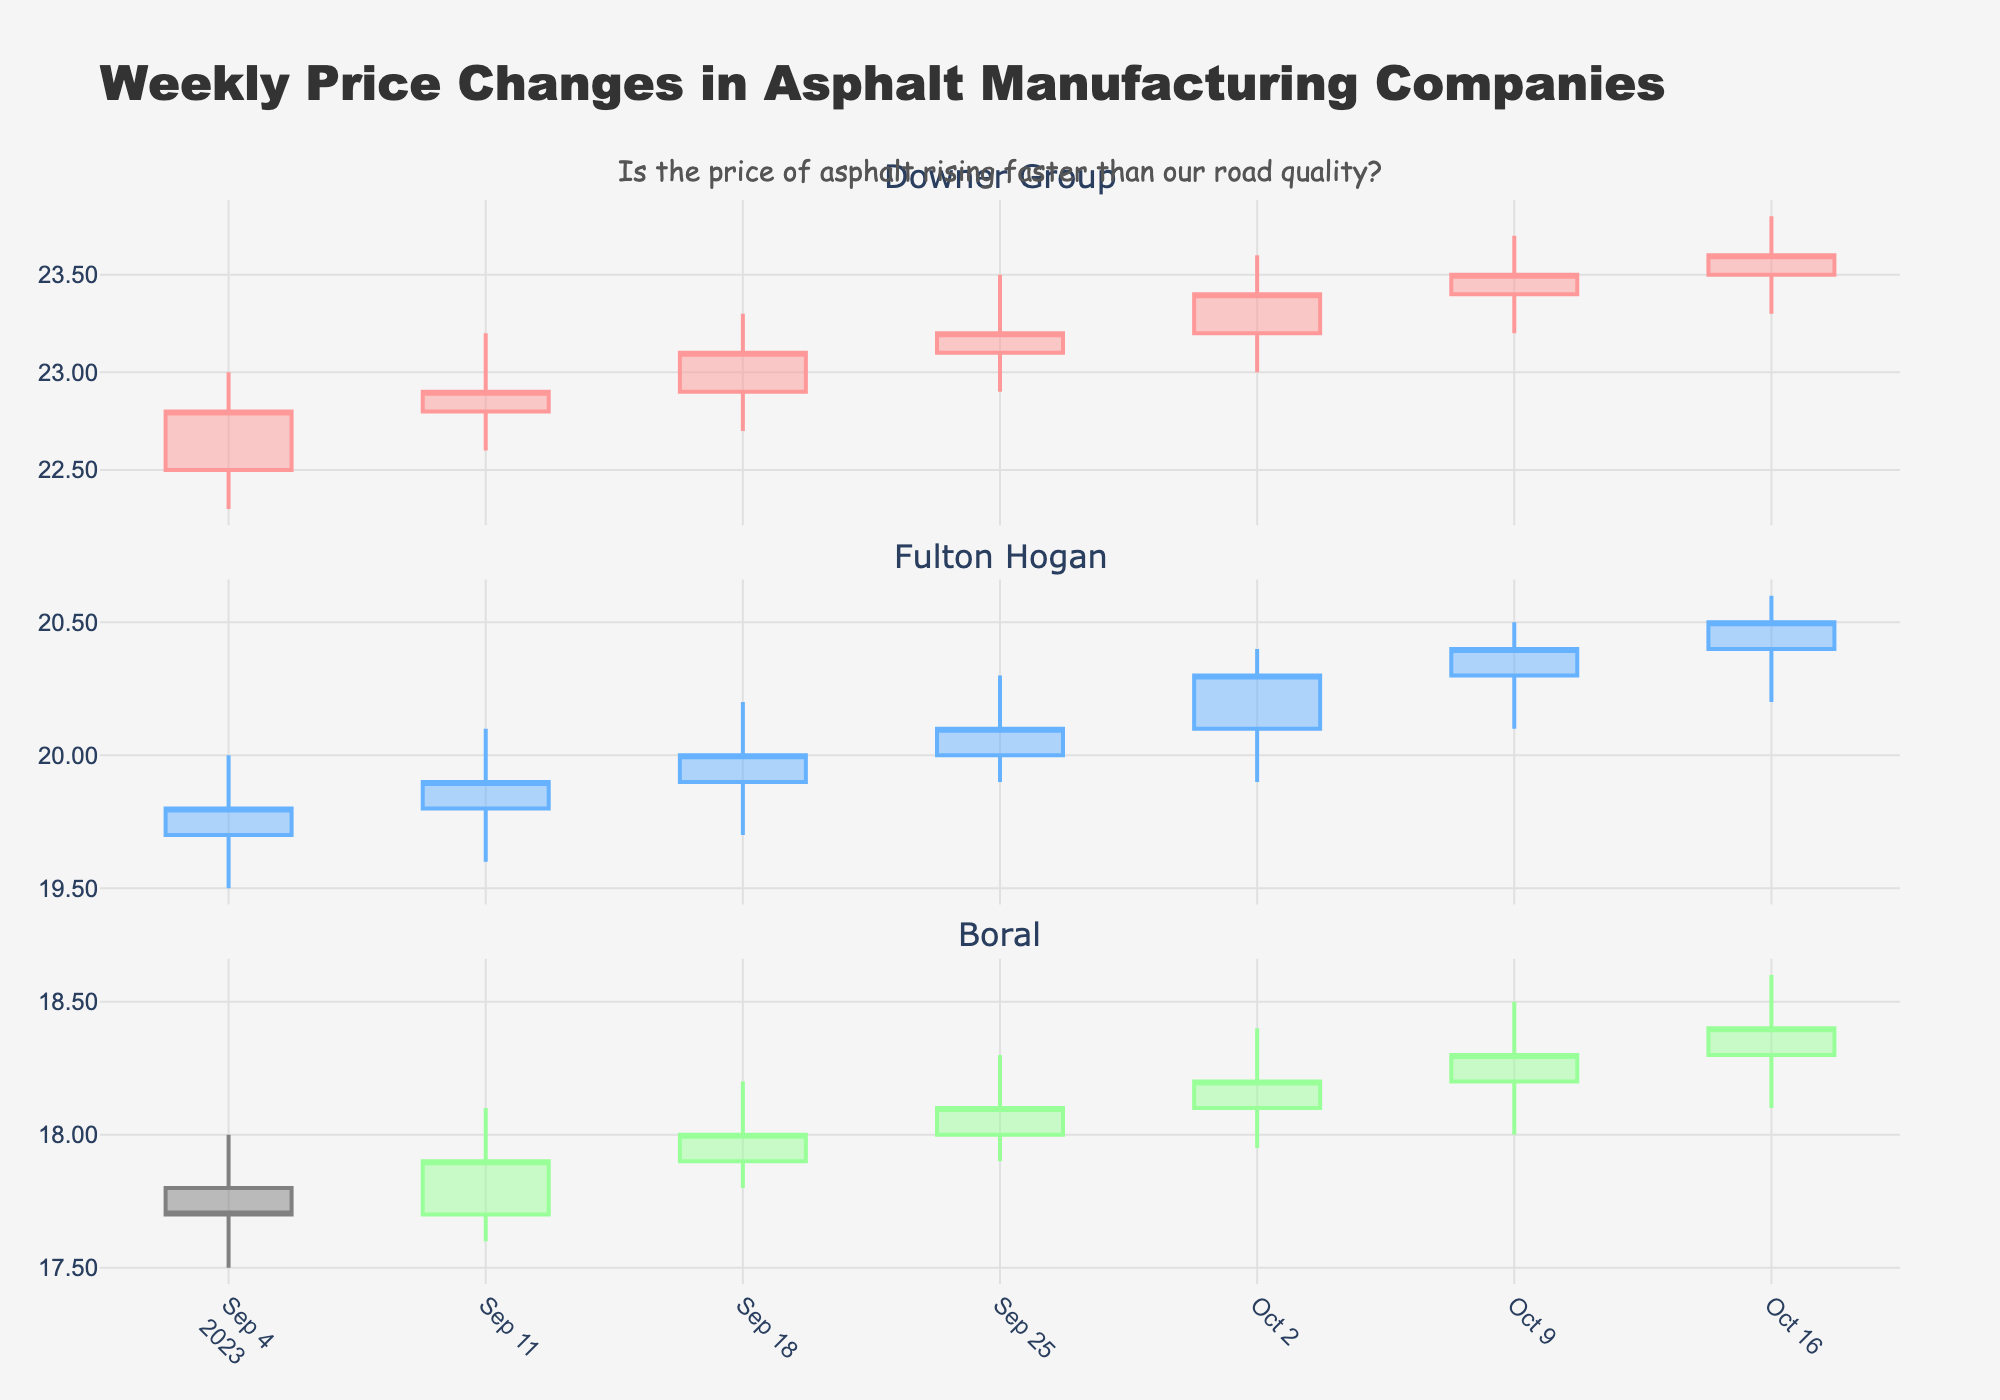What is the title of the plot? The title of the plot is usually positioned at the top and provides a brief overview of what the plot represents. In this case, it clearly states, "Weekly Price Changes in Asphalt Manufacturing Companies."
Answer: Weekly Price Changes in Asphalt Manufacturing Companies How many companies are displayed in the plot? By examining the figure, you can identify the discrete sections or subplots, each representing data for a different company. Here, you can count three subplots, each titled with the name of a company.
Answer: 3 For which company did the highest closing price occur in the week of October 16, 2023? To find the highest closing price in the week of October 16, one needs to check each company's candlestick for that week. For Downer Group, Fulton Hogan, and Boral, the closing prices are 23.60, 20.50, and 18.40 respectively. Among these, Downer Group has the highest closing price.
Answer: Downer Group What was the general trend for Fulton Hogan over this period? By looking at the candlestick colors for Fulton Hogan over the weeks, you can observe if most of the candles are increasing (upward trend) or decreasing (downward trend). The candlestick plot shows a general upward trend as the closing prices increase incrementally.
Answer: Upward trend Which company showed the least variability in their stock prices over the entire period? Variability can be inferred by the range between the high and low prices throughout the period. For each company, note the differences and compare. Boral shows the smallest range between high and low prices, indicating the least variability.
Answer: Boral During the week of September 25, 2023, how did the closing price for Downer Group compare to the closing price for Fulton Hogan? Check the closing prices for Downer Group and Fulton Hogan on September 25. Downer Group’s closing price was 23.20, while Fulton Hogan’s was 20.10. Downer Group’s closing price was higher.
Answer: Downer Group's closing price was higher How many times did Boral’s closing price increase over the weeks shown? Examine the closing prices for Boral from week to week. The closing prices for Boral increase in the weeks of September 11, September 18, September 25, October 2, and October 9. The price increased 5 times.
Answer: 5 What is the range of Downer Group's stock prices on October 2, 2023? The range can be calculated by subtracting the lowest price from the highest price for that day. On October 2, Downer Group’s highest price was 23.60, and the lowest was 23.00. The range is 23.60 - 23.00 = 0.60.
Answer: 0.60 